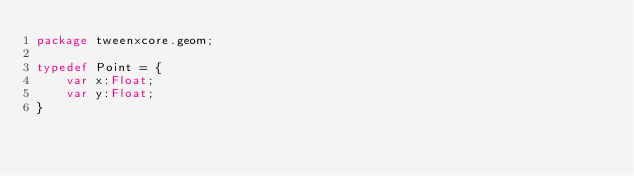Convert code to text. <code><loc_0><loc_0><loc_500><loc_500><_Haxe_>package tweenxcore.geom;

typedef Point = {
    var x:Float;
    var y:Float;
}
</code> 